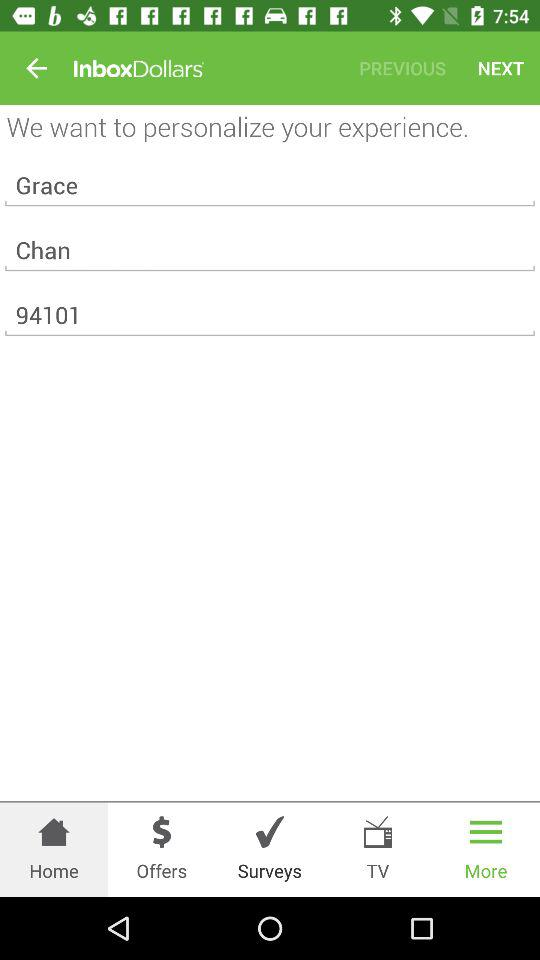What is the zip code? The zip code is 94101. 